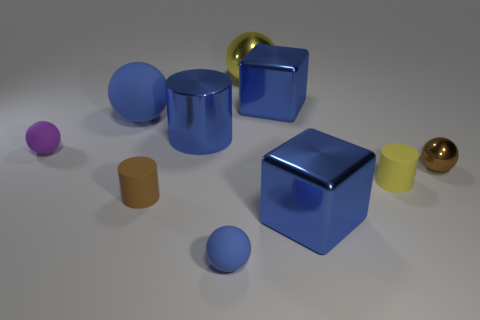Subtract all large yellow balls. How many balls are left? 4 Subtract all brown cylinders. How many cylinders are left? 2 Subtract all brown cylinders. How many blue balls are left? 2 Subtract all cylinders. How many objects are left? 7 Add 6 brown metallic spheres. How many brown metallic spheres are left? 7 Add 9 purple spheres. How many purple spheres exist? 10 Subtract 1 blue cubes. How many objects are left? 9 Subtract 3 cylinders. How many cylinders are left? 0 Subtract all purple balls. Subtract all yellow cubes. How many balls are left? 4 Subtract all tiny green rubber balls. Subtract all big metal balls. How many objects are left? 9 